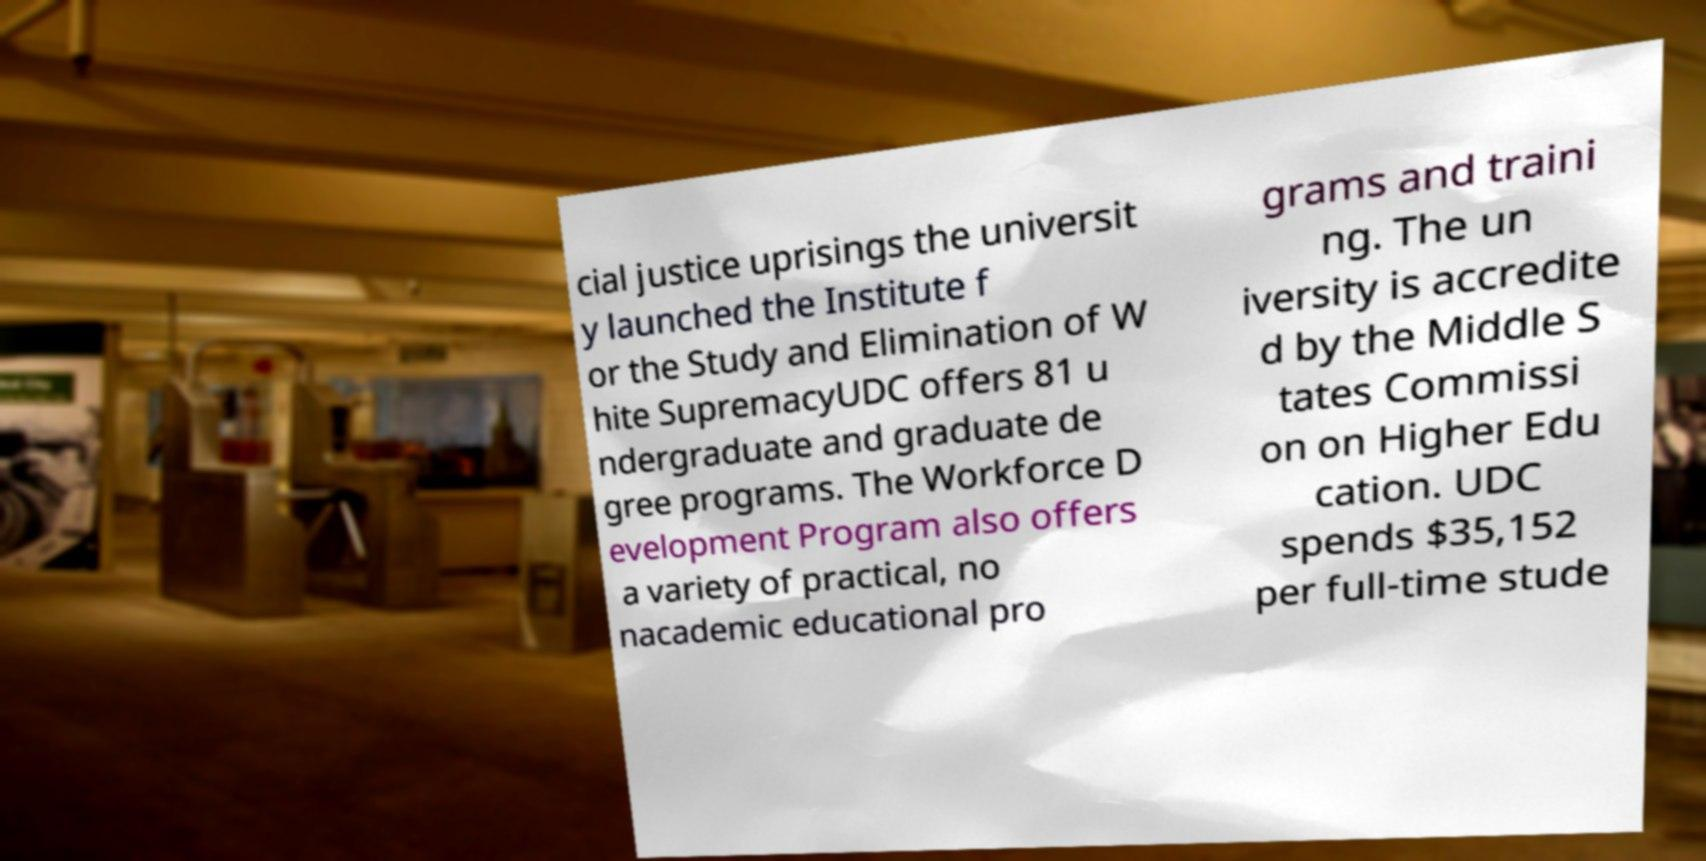What messages or text are displayed in this image? I need them in a readable, typed format. cial justice uprisings the universit y launched the Institute f or the Study and Elimination of W hite SupremacyUDC offers 81 u ndergraduate and graduate de gree programs. The Workforce D evelopment Program also offers a variety of practical, no nacademic educational pro grams and traini ng. The un iversity is accredite d by the Middle S tates Commissi on on Higher Edu cation. UDC spends $35,152 per full-time stude 